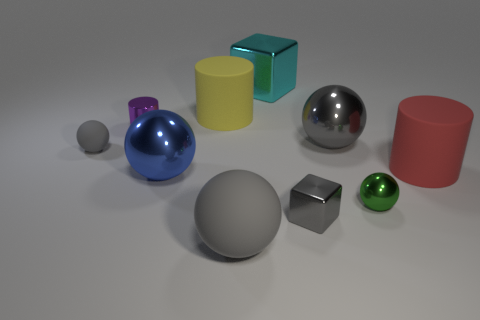The metallic object that is the same color as the tiny cube is what size?
Give a very brief answer. Large. What material is the large yellow cylinder?
Give a very brief answer. Rubber. What is the material of the block that is the same color as the tiny rubber sphere?
Your answer should be compact. Metal. There is a green shiny thing; is its size the same as the rubber cylinder on the left side of the cyan shiny thing?
Your answer should be compact. No. How many objects are either green metal objects on the right side of the purple thing or tiny yellow metal blocks?
Provide a succinct answer. 1. What shape is the gray rubber object that is right of the metal cylinder?
Provide a succinct answer. Sphere. Are there the same number of small shiny cylinders in front of the large gray rubber object and large gray spheres in front of the green sphere?
Your answer should be very brief. No. What color is the large matte thing that is on the left side of the green ball and behind the green metallic ball?
Provide a short and direct response. Yellow. What material is the large cylinder in front of the large rubber thing behind the purple object made of?
Make the answer very short. Rubber. Do the purple cylinder and the green thing have the same size?
Provide a succinct answer. Yes. 